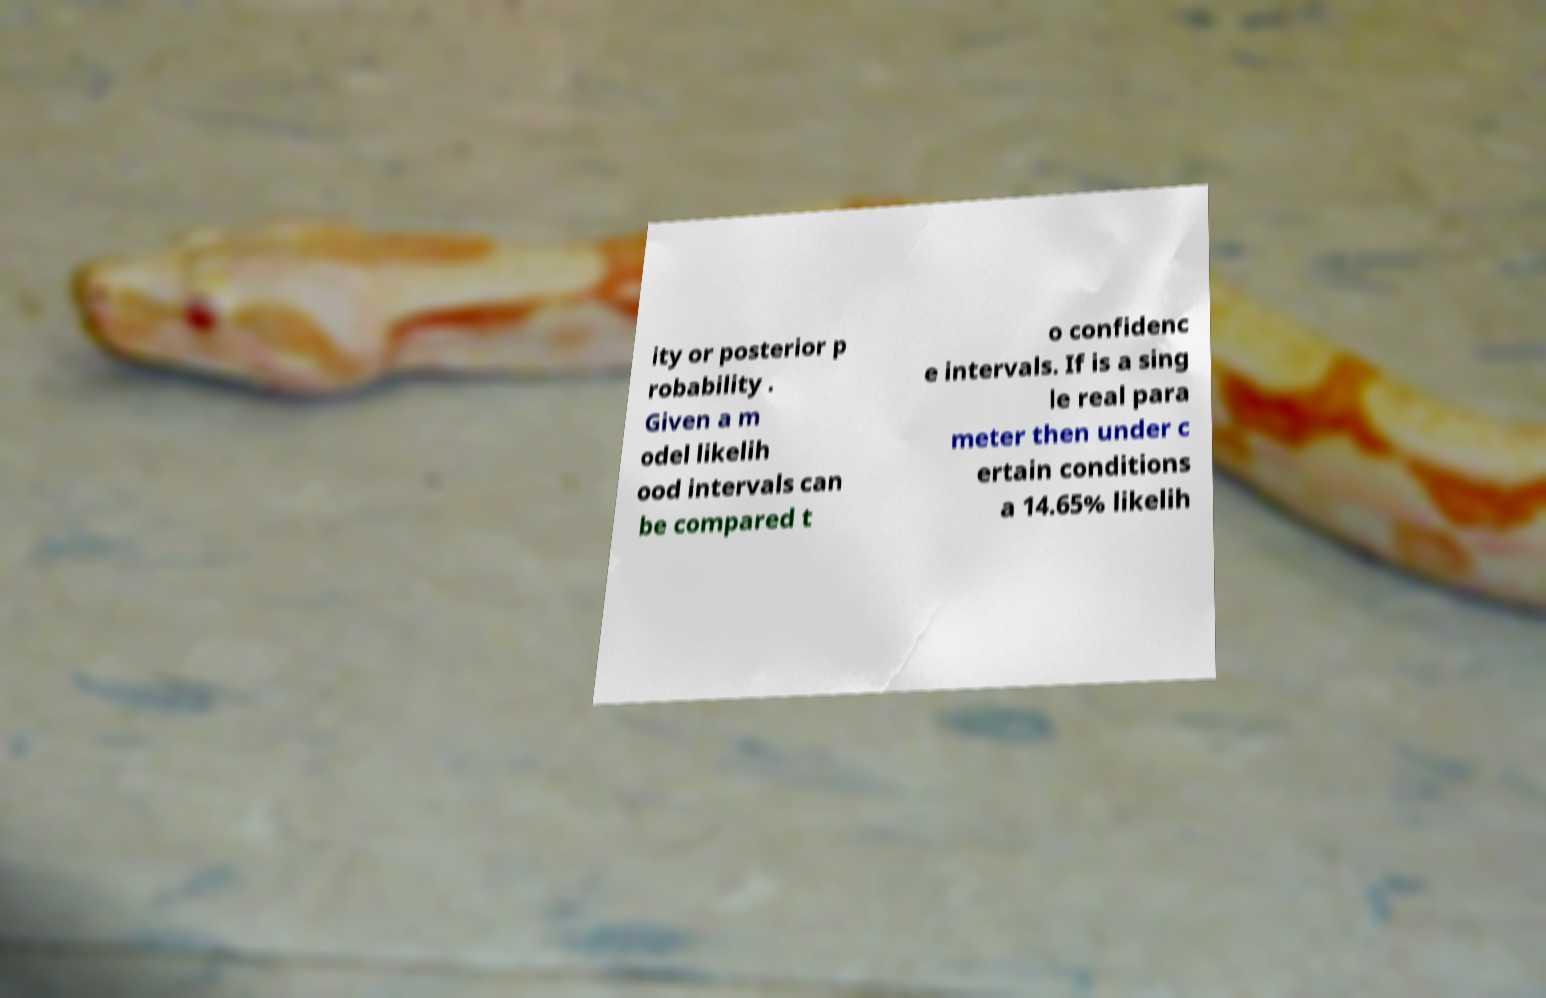Could you assist in decoding the text presented in this image and type it out clearly? ity or posterior p robability . Given a m odel likelih ood intervals can be compared t o confidenc e intervals. If is a sing le real para meter then under c ertain conditions a 14.65% likelih 